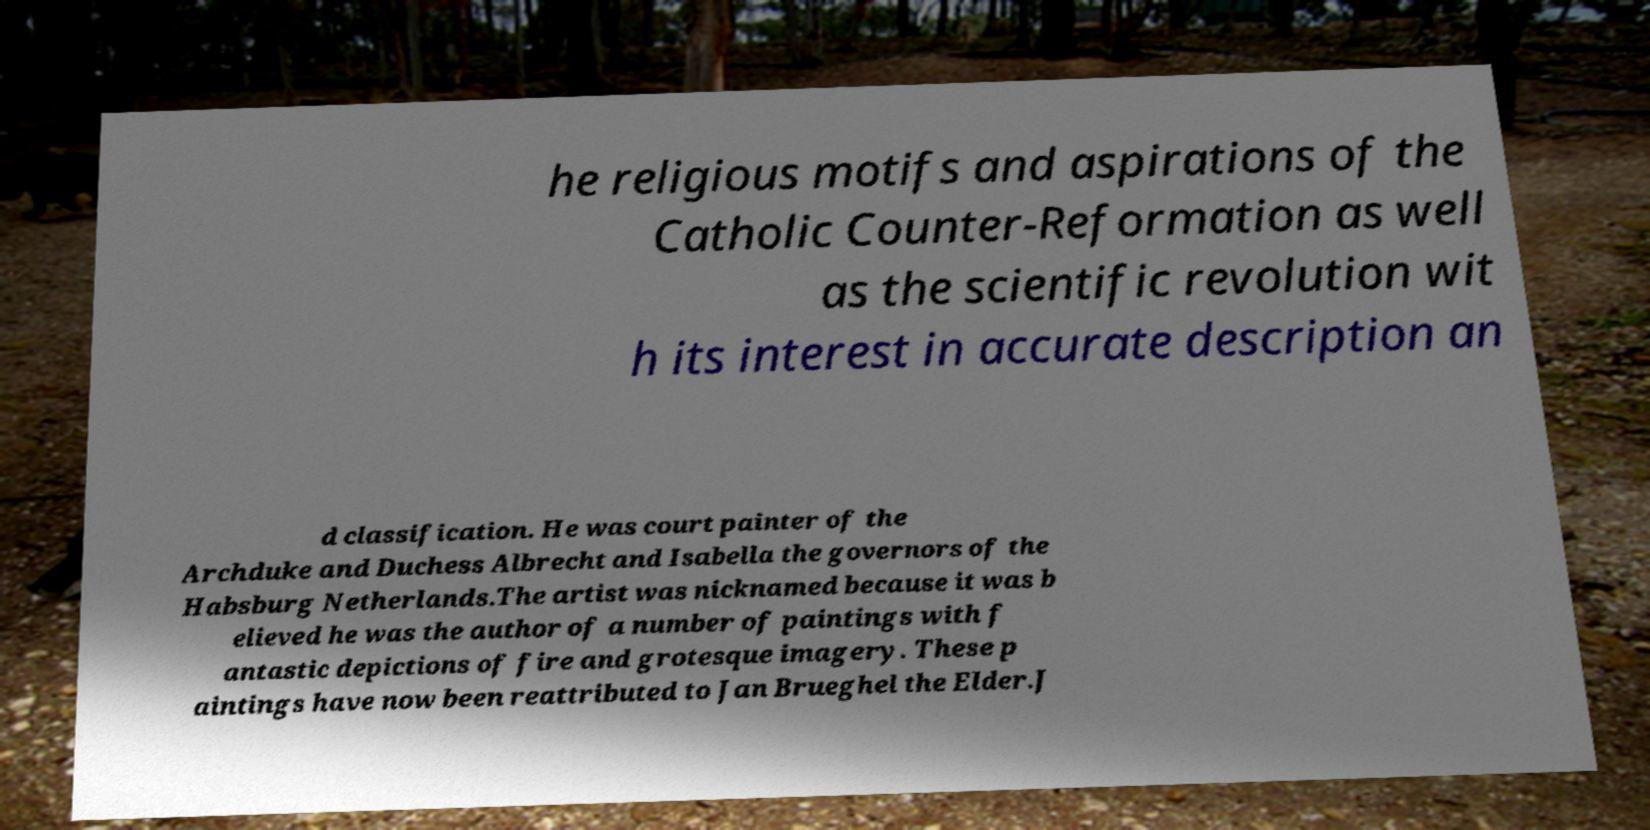What messages or text are displayed in this image? I need them in a readable, typed format. he religious motifs and aspirations of the Catholic Counter-Reformation as well as the scientific revolution wit h its interest in accurate description an d classification. He was court painter of the Archduke and Duchess Albrecht and Isabella the governors of the Habsburg Netherlands.The artist was nicknamed because it was b elieved he was the author of a number of paintings with f antastic depictions of fire and grotesque imagery. These p aintings have now been reattributed to Jan Brueghel the Elder.J 